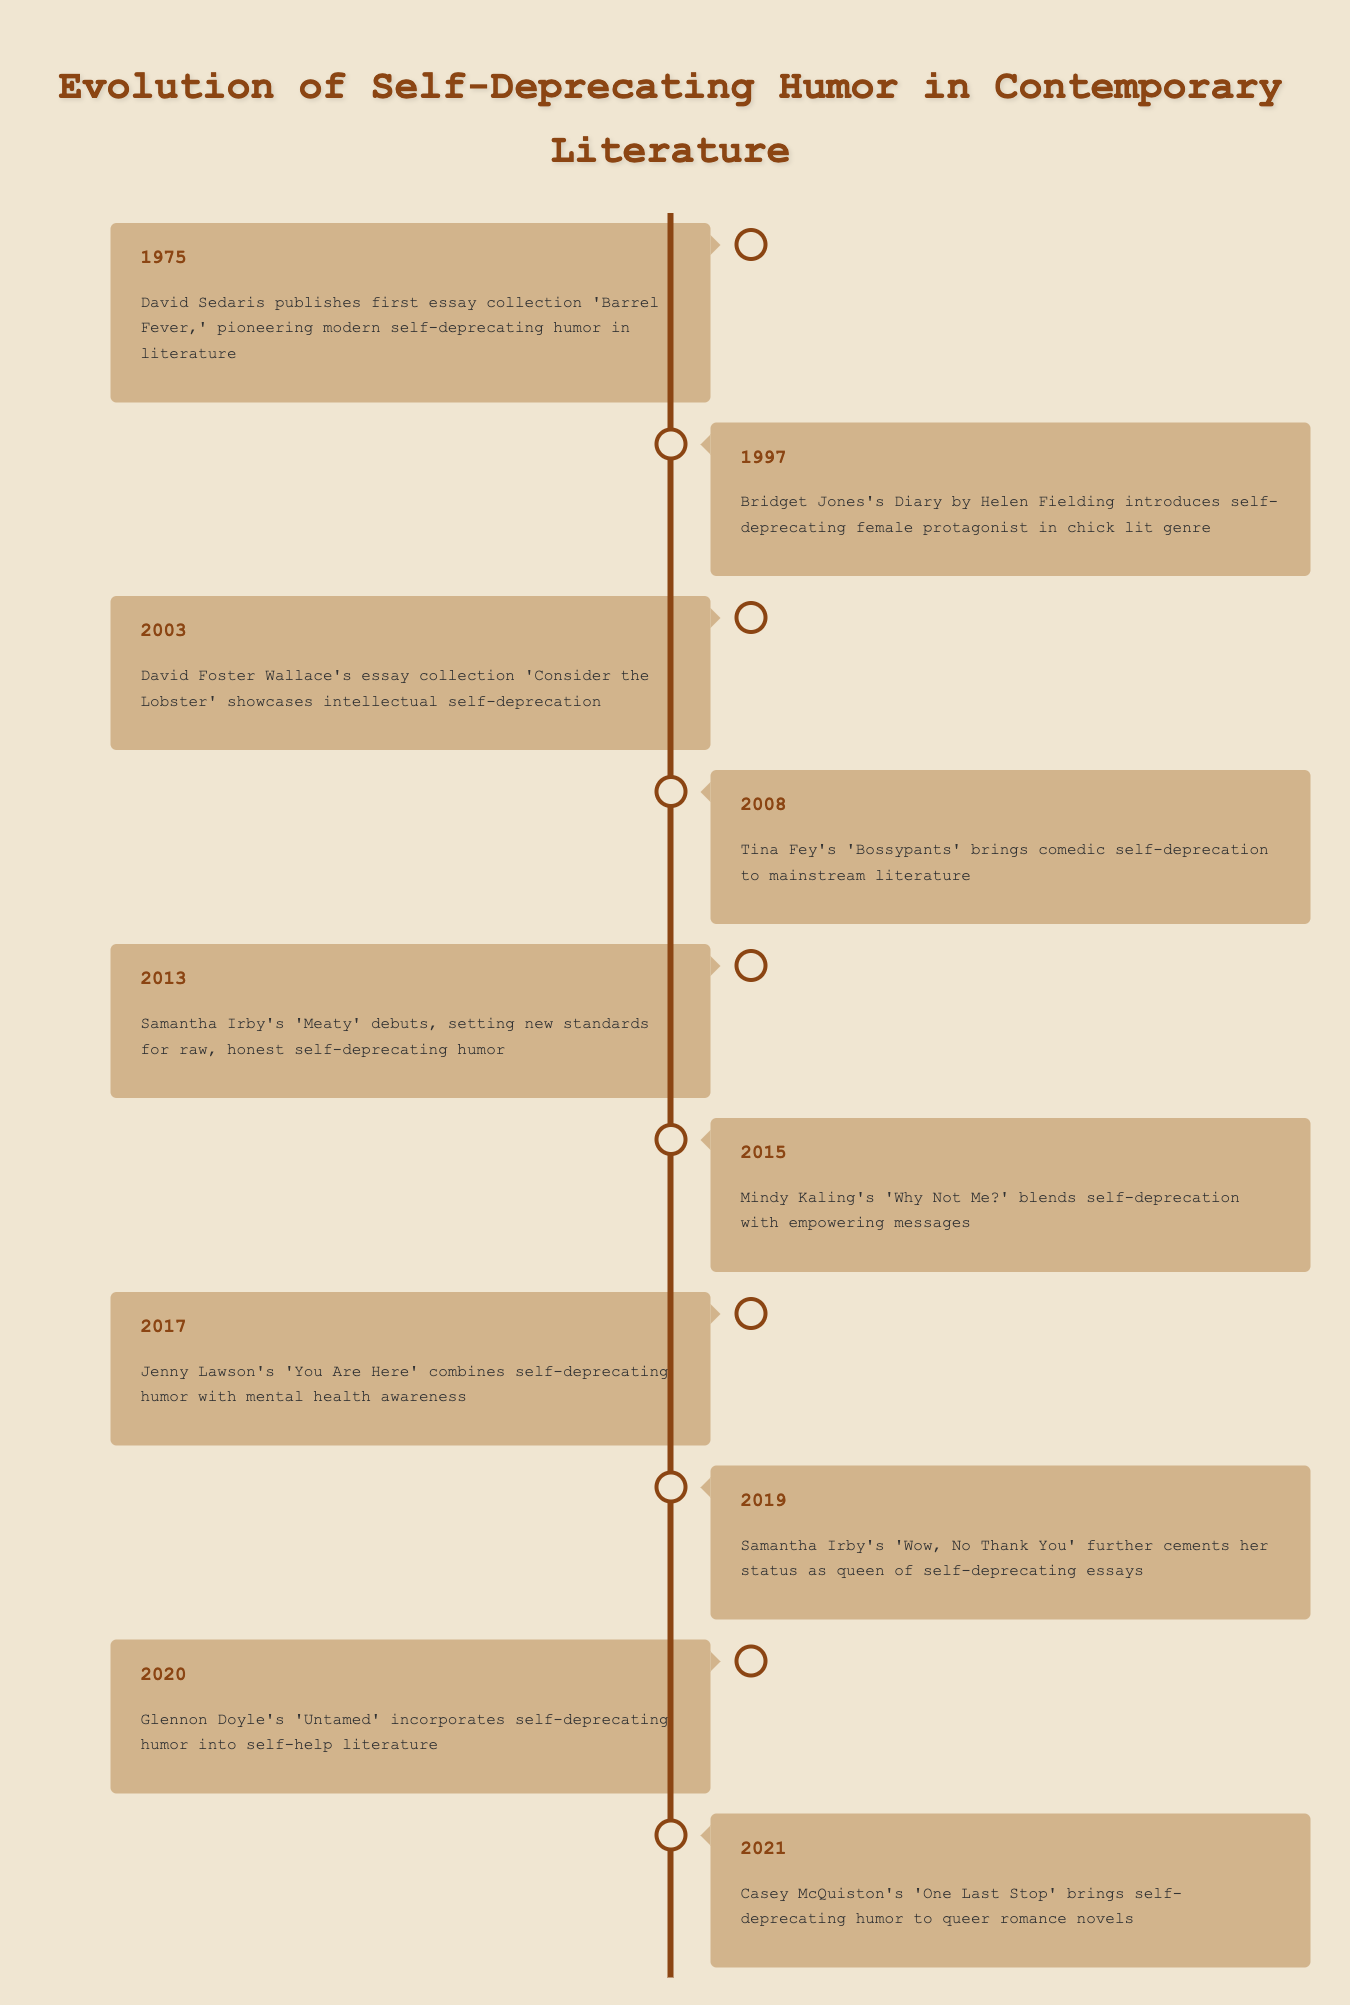What year did David Sedaris publish his first essay collection? The timeline indicates that David Sedaris published 'Barrel Fever' in 1975 as the first event listed.
Answer: 1975 Which book in 2013 set new standards for self-deprecating humor? Samantha Irby's 'Meaty' is identified in the timeline as the significant work from 2013 that raised the standards for raw, honest self-deprecating humor.
Answer: Meaty How many years are there between the publication of 'Barrel Fever' and 'Bossypants'? 'Barrel Fever' was published in 1975 and 'Bossypants' in 2008. To find the difference, subtract 1975 from 2008, which gives us 33 years.
Answer: 33 years Did Mindy Kaling's 'Why Not Me?' include self-deprecating humor? According to the timeline for 2015, 'Why Not Me?' blends self-deprecation with empowering messages, suggesting it indeed features self-deprecating humor.
Answer: Yes Which author is mentioned both in 2013 and 2019? The timeline highlights Samantha Irby as the author linked with 'Meaty' in 2013 and her work 'Wow, No Thank You' in 2019, confirming she appears in both years.
Answer: Samantha Irby What is the trend of self-deprecating humor in literature from 2008 to 2021? Between 2008, with Tina Fey's work, and 2021, with Casey McQuiston's novel, there are multiple mentions of self-deprecating humor evolving in different genres, implying that it has become more mainstream and diverse.
Answer: Evolving trend In which year was a self-deprecating female protagonist introduced in the chick lit genre? The timeline notes that in 1997, Helen Fielding's 'Bridget Jones's Diary' introduced a self-deprecating female protagonist.
Answer: 1997 What is the earliest year noted for self-deprecating humor in the timeline? The earliest event listed is from the year 1975, marking David Sedaris's contributions to self-deprecating humor.
Answer: 1975 How many works are focused on mental health awareness mentioned in the timeline? Only one work, Jenny Lawson's 'You Are Here' from 2017, specifically focuses on self-deprecating humor combined with mental health awareness, as shown in the timeline.
Answer: 1 work 